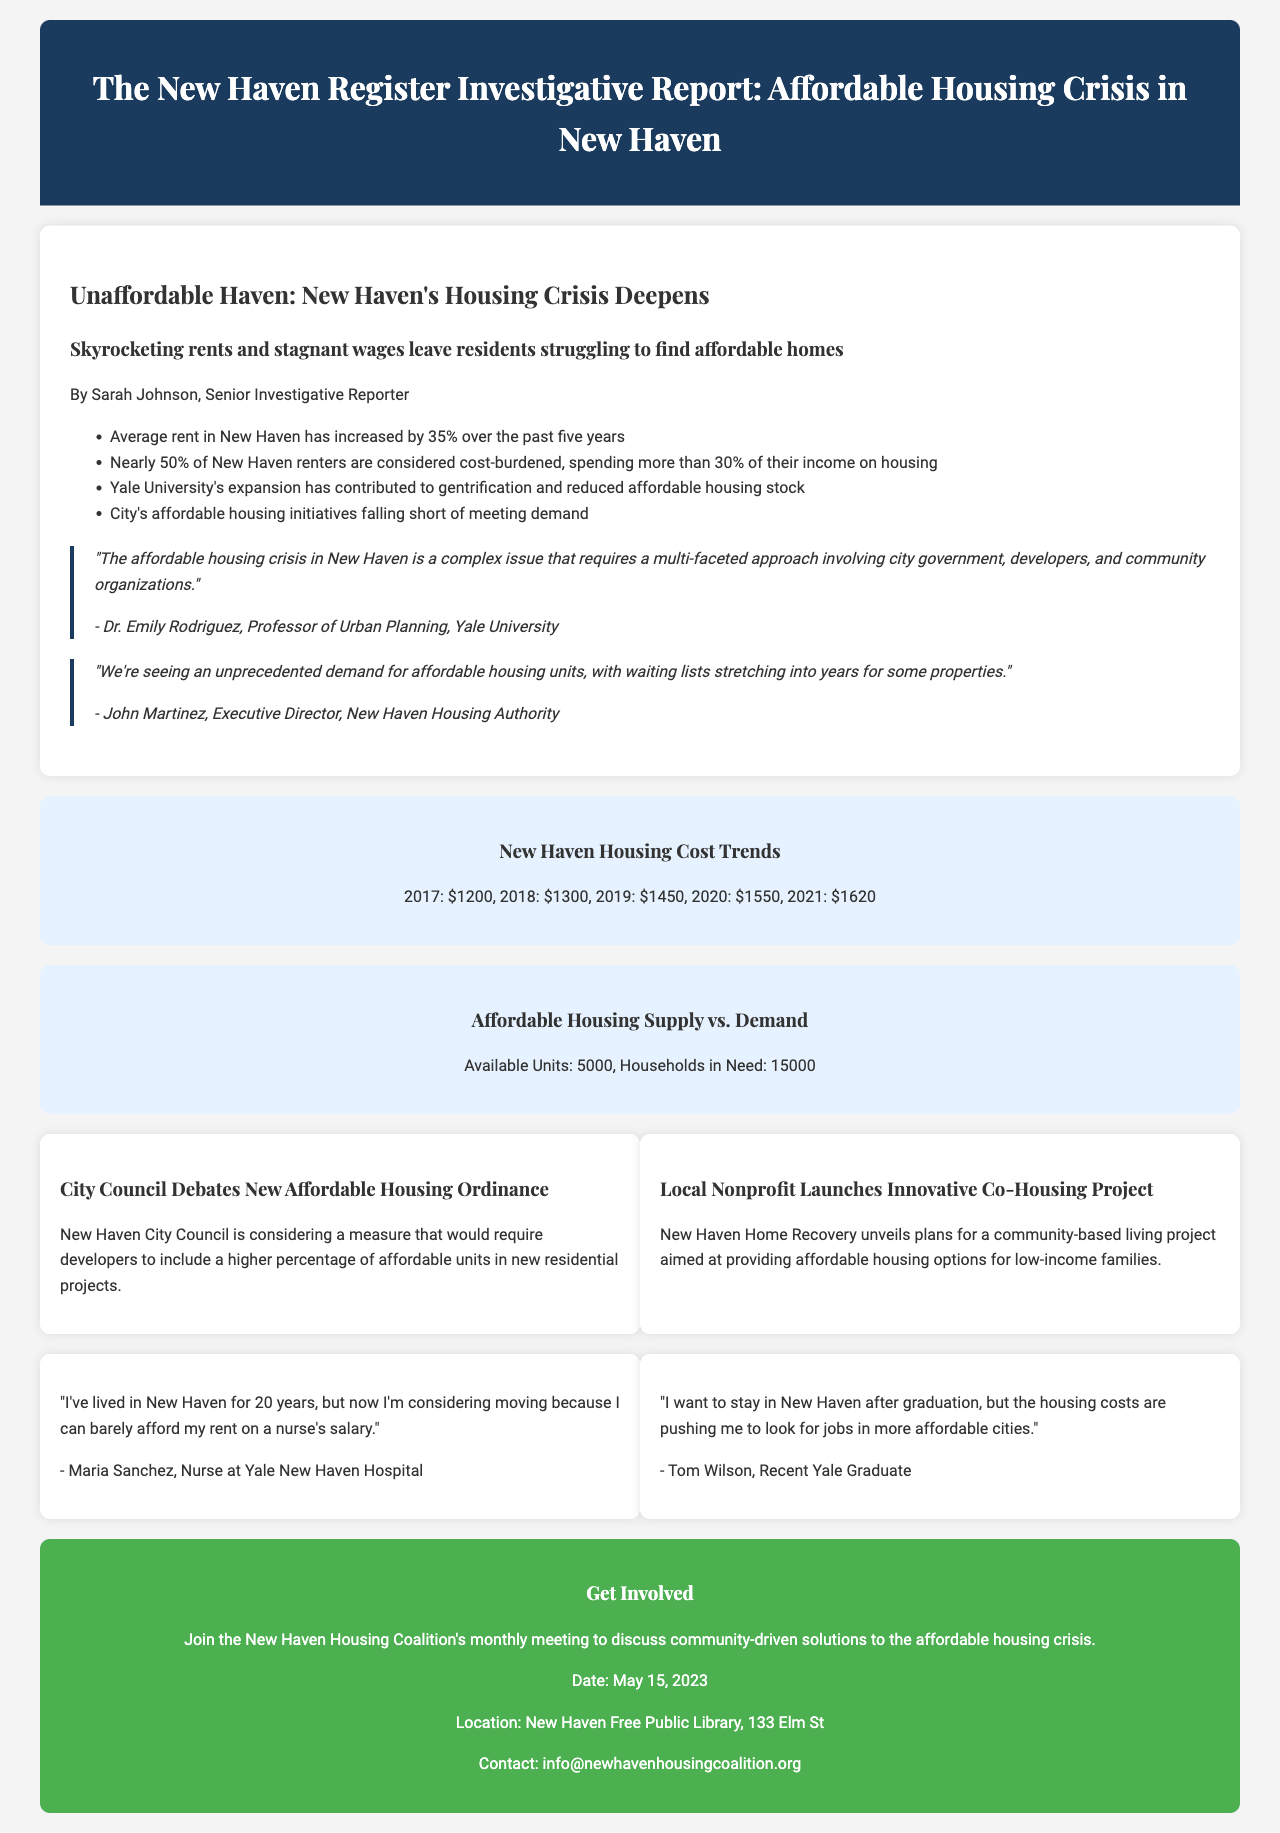What is the average rent increase over the past five years? The average rent in New Haven has increased by 35% over the past five years, indicating a significant rise in housing costs.
Answer: 35% How many renters are cost-burdened in New Haven? Nearly 50% of New Haven renters are considered cost-burdened, which reflects the struggle of many residents in affording their housing.
Answer: 50% Who is the Executive Director of the New Haven Housing Authority? The document includes an expert quote from John Martinez, who holds the position of Executive Director at the New Haven Housing Authority.
Answer: John Martinez What is the date of the New Haven Housing Coalition's monthly meeting? The call to action section provides the date for community engagement, which is an important detail for interested attendees.
Answer: May 15, 2023 What initiative is New Haven considering to address affordable housing? The document mentions a new ordinance that the New Haven City Council is debating, aiming to enhance affordable housing in the city.
Answer: Affordable housing ordinance According to Dr. Emily Rodriguez, what is required to address the affordable housing crisis? Dr. Emily Rodriguez emphasizes that a multi-faceted approach is necessary, highlighting the importance of collaboration among various stakeholders.
Answer: Multi-faceted approach What is the total number of households in need of affordable housing in New Haven? The infographic titled "Affordable Housing Supply vs. Demand" indicates the scale of the issue by showing how many households are affected compared to available units.
Answer: 15000 How long are waiting lists for affordable housing units? John Martinez states that waiting lists for affordable housing units can stretch into years, revealing the demand for these units far exceeds supply.
Answer: Years 